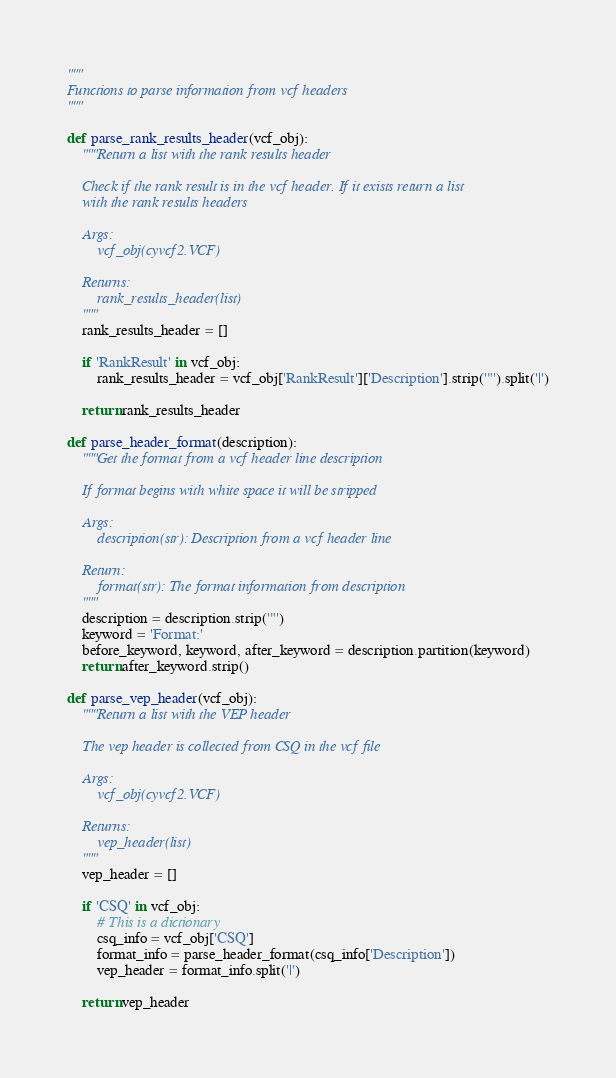Convert code to text. <code><loc_0><loc_0><loc_500><loc_500><_Python_>"""
Functions to parse information from vcf headers
"""

def parse_rank_results_header(vcf_obj):
    """Return a list with the rank results header
    
    Check if the rank result is in the vcf header. If it exists return a list 
    with the rank results headers
    
    Args:
        vcf_obj(cyvcf2.VCF)
    
    Returns:
        rank_results_header(list)
    """
    rank_results_header = []
    
    if 'RankResult' in vcf_obj:
        rank_results_header = vcf_obj['RankResult']['Description'].strip('"').split('|')
    
    return rank_results_header

def parse_header_format(description):
    """Get the format from a vcf header line description
    
    If format begins with white space it will be stripped
    
    Args:
        description(str): Description from a vcf header line
    
    Return:
        format(str): The format information from description
    """
    description = description.strip('"')
    keyword = 'Format:'
    before_keyword, keyword, after_keyword = description.partition(keyword)
    return after_keyword.strip()

def parse_vep_header(vcf_obj):
    """Return a list with the VEP header
    
    The vep header is collected from CSQ in the vcf file
    
    Args:
        vcf_obj(cyvcf2.VCF)
    
    Returns:
        vep_header(list)
    """
    vep_header = []
    
    if 'CSQ' in vcf_obj:
        # This is a dictionary
        csq_info = vcf_obj['CSQ']
        format_info = parse_header_format(csq_info['Description'])
        vep_header = format_info.split('|')
    
    return vep_header</code> 